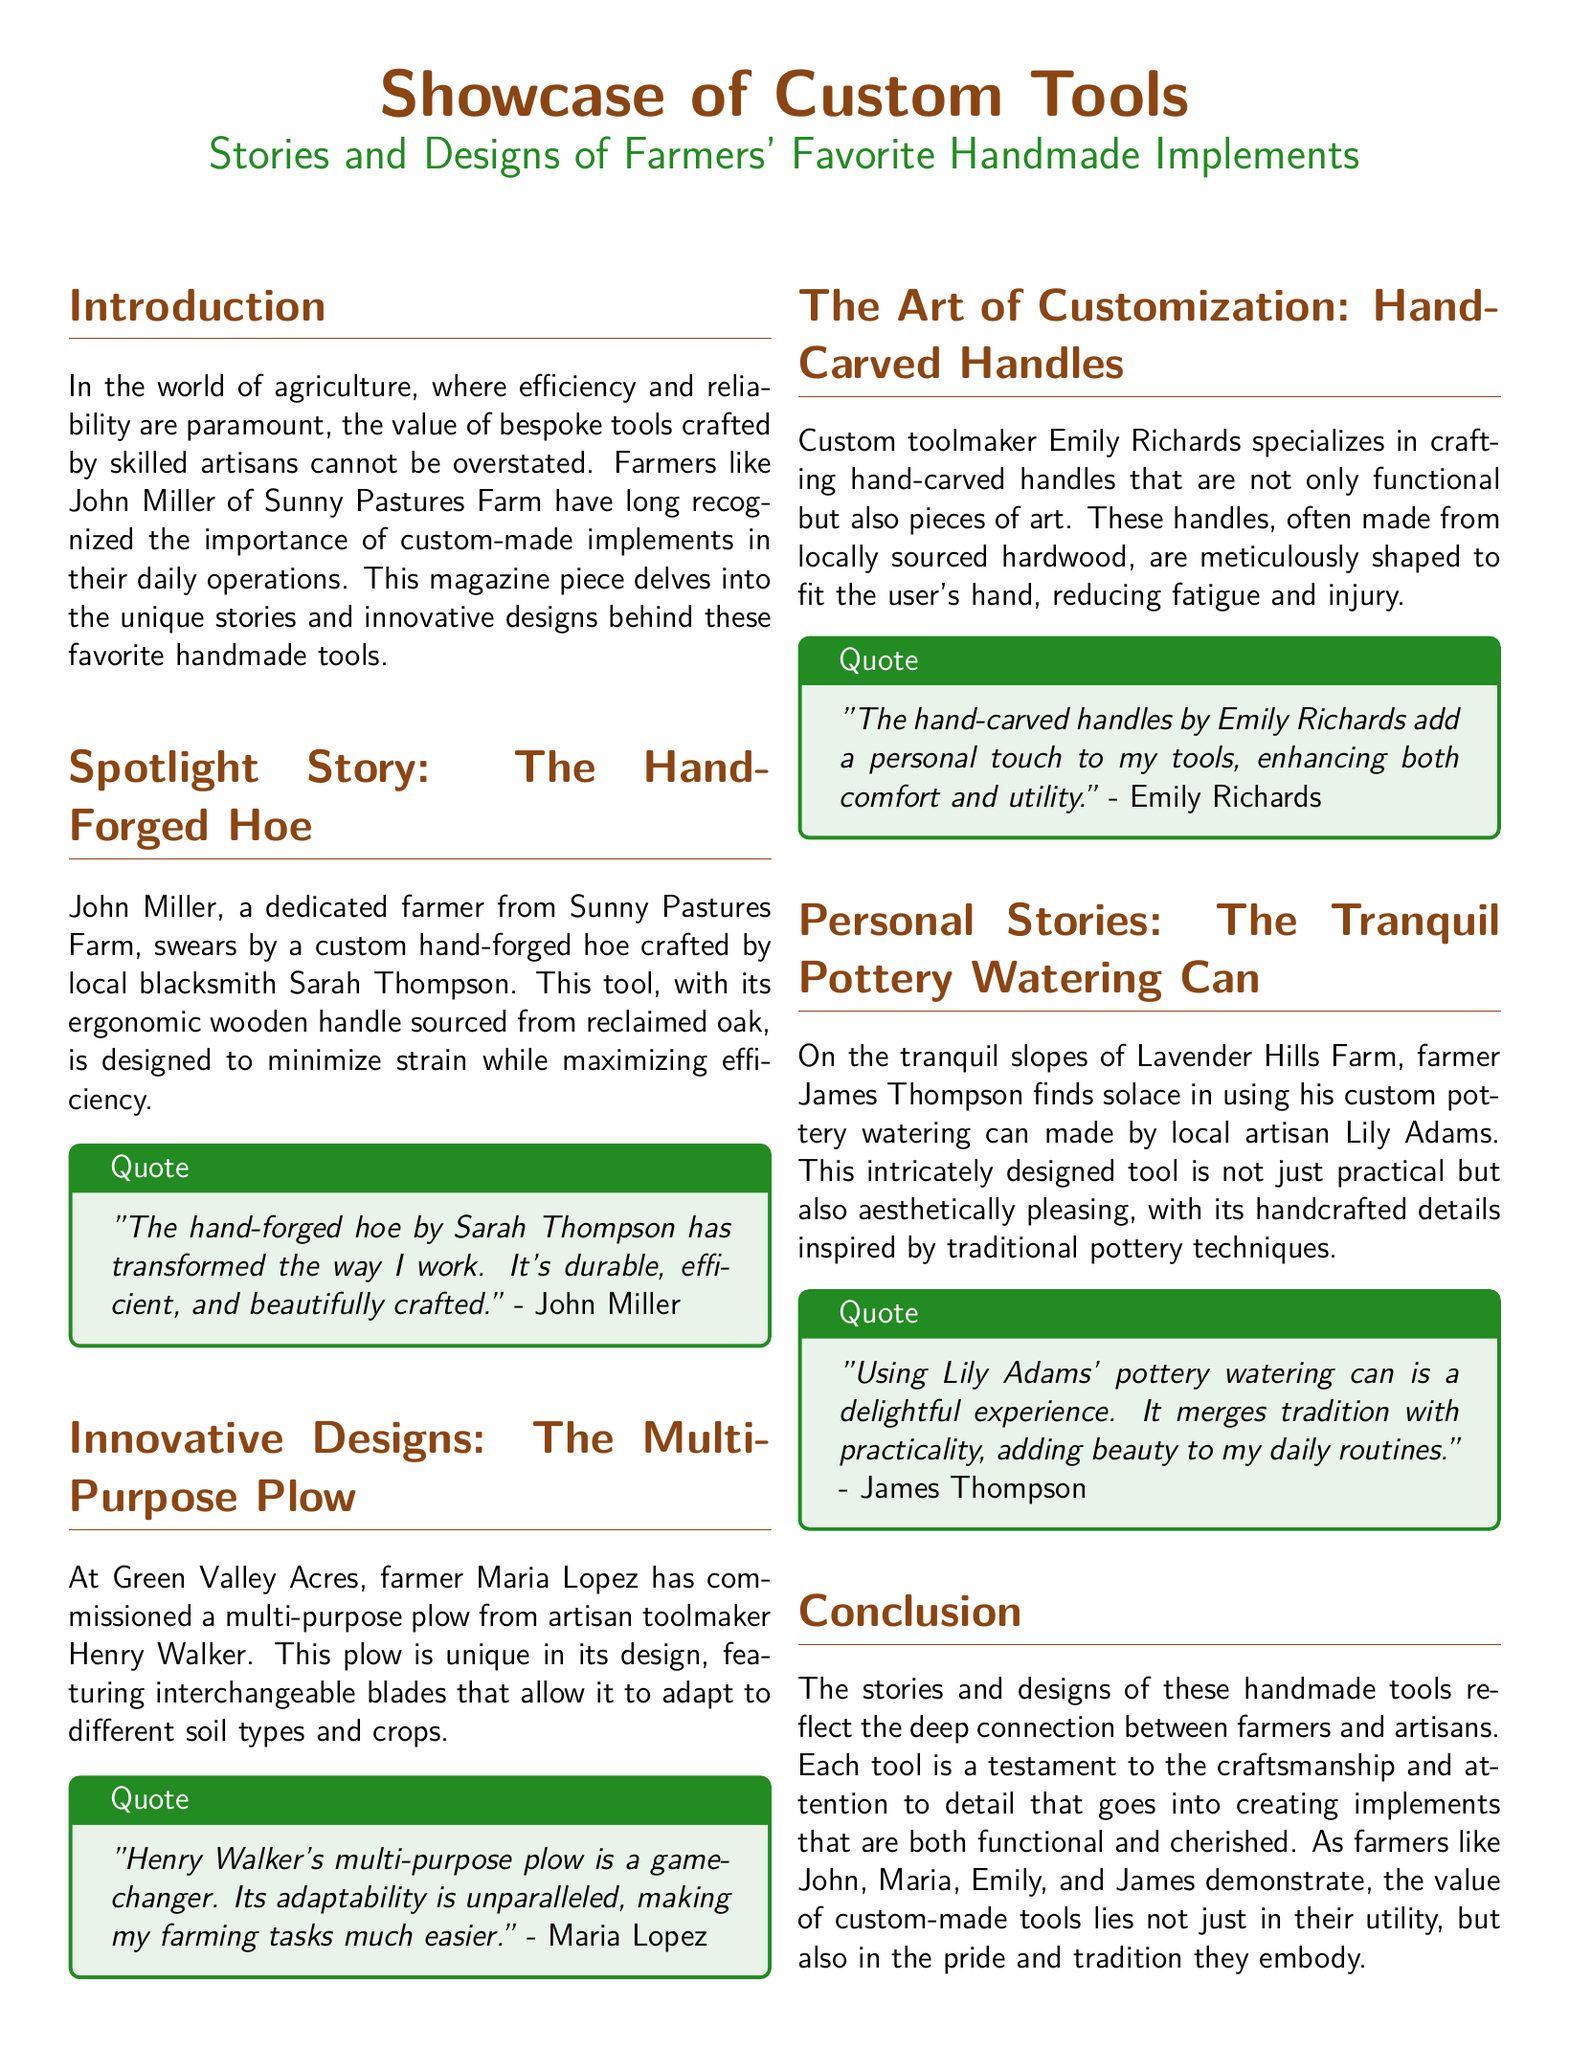What is the name of the farmer featured in the spotlight story? The spotlight story features John Miller from Sunny Pastures Farm.
Answer: John Miller Who crafted the hand-forged hoe? The hand-forged hoe was crafted by local blacksmith Sarah Thompson.
Answer: Sarah Thompson What unique feature does Maria Lopez's multi-purpose plow have? Maria Lopez's multi-purpose plow features interchangeable blades for adaptability.
Answer: Interchangeable blades Which material is used for the hand-carved handles? The hand-carved handles are made from locally sourced hardwood.
Answer: Hardwood What is James Thompson's custom tool made of? James Thompson's custom tool, the watering can, is made of pottery.
Answer: Pottery What do the farmers' stories highlight about their tools? The farmers' stories highlight the connection between farmers and artisans.
Answer: Connection How does the document categorize the sections? The document categorizes the sections as stories, designs, and personal anecdotes.
Answer: Stories and designs What type of craftsman is Emily Richards? Emily Richards is a custom toolmaker.
Answer: Custom toolmaker 